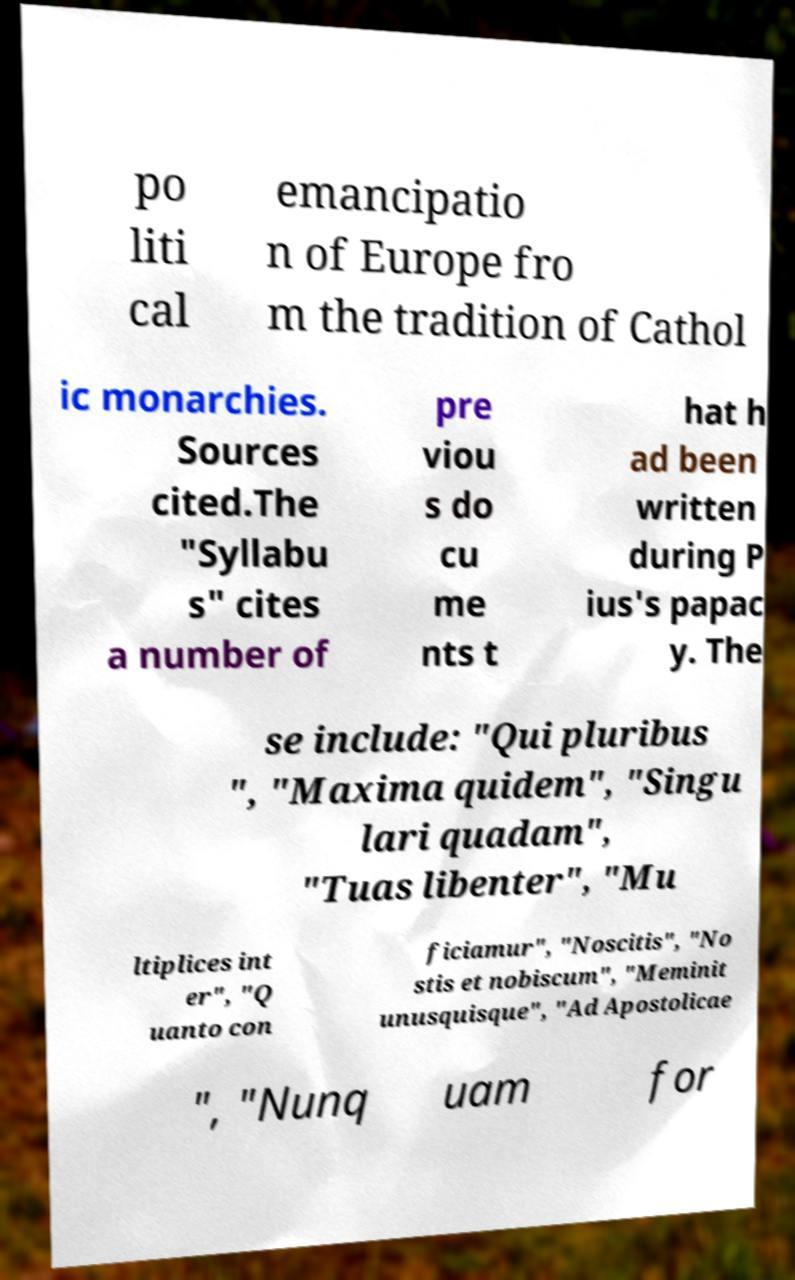There's text embedded in this image that I need extracted. Can you transcribe it verbatim? po liti cal emancipatio n of Europe fro m the tradition of Cathol ic monarchies. Sources cited.The "Syllabu s" cites a number of pre viou s do cu me nts t hat h ad been written during P ius's papac y. The se include: "Qui pluribus ", "Maxima quidem", "Singu lari quadam", "Tuas libenter", "Mu ltiplices int er", "Q uanto con ficiamur", "Noscitis", "No stis et nobiscum", "Meminit unusquisque", "Ad Apostolicae ", "Nunq uam for 